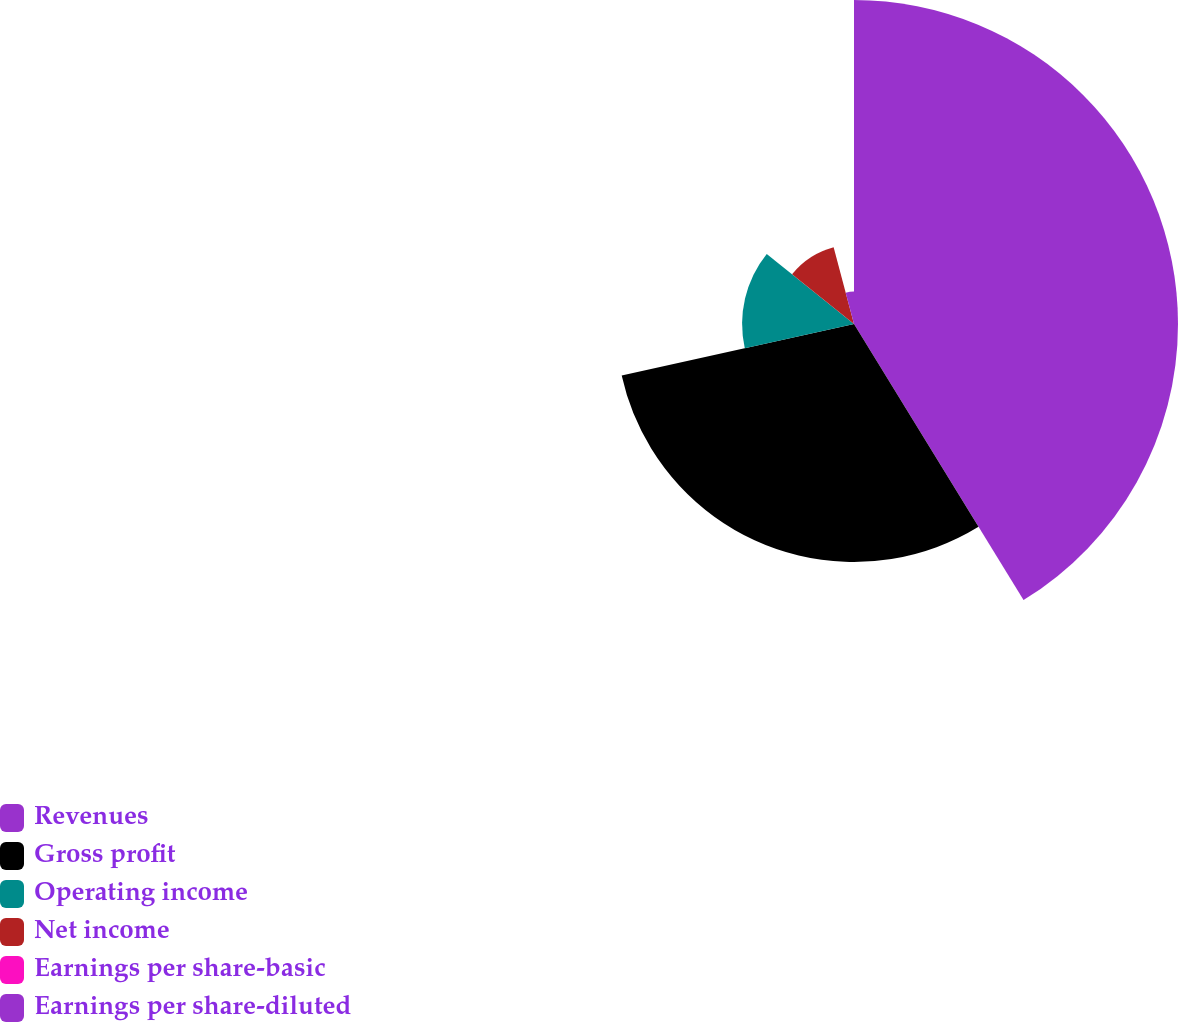<chart> <loc_0><loc_0><loc_500><loc_500><pie_chart><fcel>Revenues<fcel>Gross profit<fcel>Operating income<fcel>Net income<fcel>Earnings per share-basic<fcel>Earnings per share-diluted<nl><fcel>41.24%<fcel>30.29%<fcel>14.24%<fcel>10.11%<fcel>0.0%<fcel>4.13%<nl></chart> 